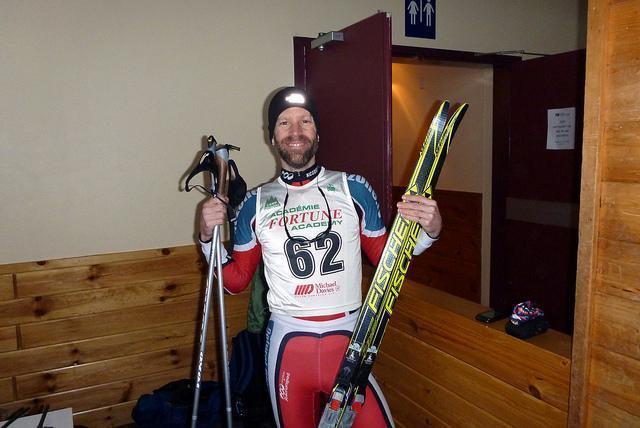How many people are visible?
Give a very brief answer. 1. How many red cars are there?
Give a very brief answer. 0. 